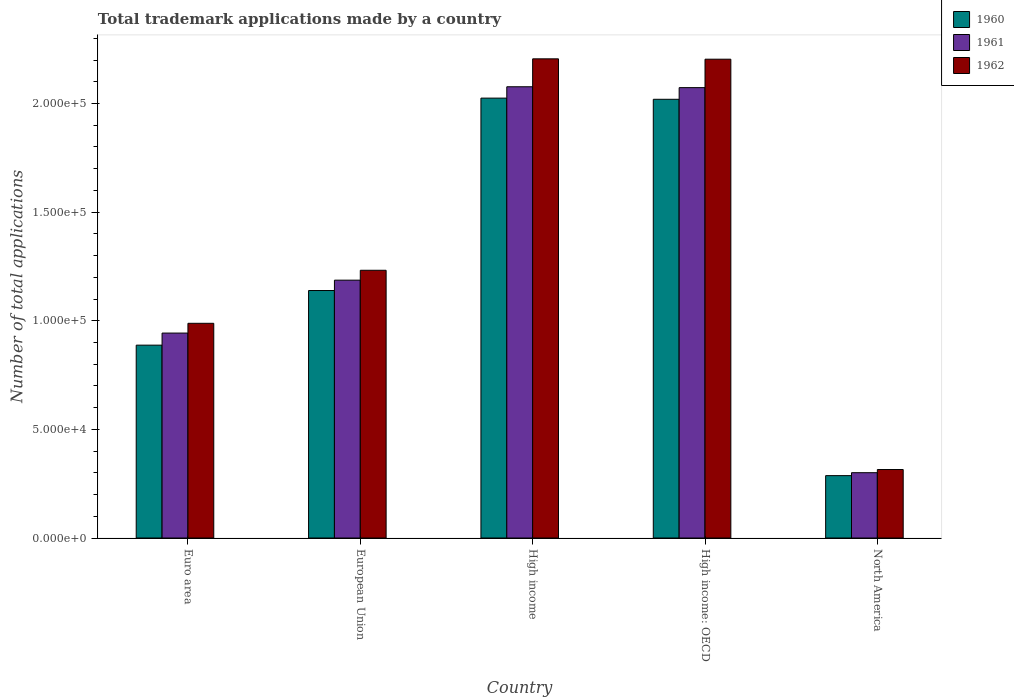How many different coloured bars are there?
Your answer should be compact. 3. How many bars are there on the 4th tick from the left?
Keep it short and to the point. 3. In how many cases, is the number of bars for a given country not equal to the number of legend labels?
Provide a succinct answer. 0. What is the number of applications made by in 1960 in European Union?
Ensure brevity in your answer.  1.14e+05. Across all countries, what is the maximum number of applications made by in 1961?
Offer a terse response. 2.08e+05. Across all countries, what is the minimum number of applications made by in 1960?
Ensure brevity in your answer.  2.87e+04. In which country was the number of applications made by in 1960 minimum?
Provide a succinct answer. North America. What is the total number of applications made by in 1961 in the graph?
Ensure brevity in your answer.  6.58e+05. What is the difference between the number of applications made by in 1960 in European Union and that in North America?
Your answer should be compact. 8.52e+04. What is the difference between the number of applications made by in 1962 in North America and the number of applications made by in 1961 in High income: OECD?
Provide a succinct answer. -1.76e+05. What is the average number of applications made by in 1961 per country?
Provide a succinct answer. 1.32e+05. What is the difference between the number of applications made by of/in 1961 and number of applications made by of/in 1962 in High income?
Your response must be concise. -1.29e+04. In how many countries, is the number of applications made by in 1960 greater than 180000?
Make the answer very short. 2. What is the ratio of the number of applications made by in 1962 in Euro area to that in European Union?
Provide a succinct answer. 0.8. What is the difference between the highest and the second highest number of applications made by in 1962?
Make the answer very short. 9.73e+04. What is the difference between the highest and the lowest number of applications made by in 1960?
Give a very brief answer. 1.74e+05. What does the 1st bar from the right in Euro area represents?
Ensure brevity in your answer.  1962. Is it the case that in every country, the sum of the number of applications made by in 1961 and number of applications made by in 1962 is greater than the number of applications made by in 1960?
Provide a short and direct response. Yes. How many countries are there in the graph?
Ensure brevity in your answer.  5. What is the difference between two consecutive major ticks on the Y-axis?
Provide a succinct answer. 5.00e+04. Does the graph contain grids?
Keep it short and to the point. No. How many legend labels are there?
Your response must be concise. 3. What is the title of the graph?
Ensure brevity in your answer.  Total trademark applications made by a country. Does "2002" appear as one of the legend labels in the graph?
Ensure brevity in your answer.  No. What is the label or title of the Y-axis?
Offer a terse response. Number of total applications. What is the Number of total applications in 1960 in Euro area?
Ensure brevity in your answer.  8.88e+04. What is the Number of total applications of 1961 in Euro area?
Ensure brevity in your answer.  9.43e+04. What is the Number of total applications in 1962 in Euro area?
Provide a short and direct response. 9.88e+04. What is the Number of total applications in 1960 in European Union?
Offer a very short reply. 1.14e+05. What is the Number of total applications of 1961 in European Union?
Provide a short and direct response. 1.19e+05. What is the Number of total applications in 1962 in European Union?
Offer a terse response. 1.23e+05. What is the Number of total applications of 1960 in High income?
Give a very brief answer. 2.02e+05. What is the Number of total applications of 1961 in High income?
Offer a very short reply. 2.08e+05. What is the Number of total applications in 1962 in High income?
Keep it short and to the point. 2.21e+05. What is the Number of total applications of 1960 in High income: OECD?
Your answer should be compact. 2.02e+05. What is the Number of total applications in 1961 in High income: OECD?
Your response must be concise. 2.07e+05. What is the Number of total applications in 1962 in High income: OECD?
Provide a succinct answer. 2.20e+05. What is the Number of total applications in 1960 in North America?
Your answer should be very brief. 2.87e+04. What is the Number of total applications of 1961 in North America?
Provide a succinct answer. 3.01e+04. What is the Number of total applications in 1962 in North America?
Your answer should be very brief. 3.15e+04. Across all countries, what is the maximum Number of total applications of 1960?
Provide a succinct answer. 2.02e+05. Across all countries, what is the maximum Number of total applications of 1961?
Offer a very short reply. 2.08e+05. Across all countries, what is the maximum Number of total applications in 1962?
Provide a short and direct response. 2.21e+05. Across all countries, what is the minimum Number of total applications of 1960?
Make the answer very short. 2.87e+04. Across all countries, what is the minimum Number of total applications of 1961?
Your response must be concise. 3.01e+04. Across all countries, what is the minimum Number of total applications of 1962?
Ensure brevity in your answer.  3.15e+04. What is the total Number of total applications of 1960 in the graph?
Provide a short and direct response. 6.36e+05. What is the total Number of total applications of 1961 in the graph?
Your response must be concise. 6.58e+05. What is the total Number of total applications of 1962 in the graph?
Your response must be concise. 6.95e+05. What is the difference between the Number of total applications in 1960 in Euro area and that in European Union?
Offer a terse response. -2.51e+04. What is the difference between the Number of total applications in 1961 in Euro area and that in European Union?
Make the answer very short. -2.44e+04. What is the difference between the Number of total applications of 1962 in Euro area and that in European Union?
Your response must be concise. -2.44e+04. What is the difference between the Number of total applications in 1960 in Euro area and that in High income?
Ensure brevity in your answer.  -1.14e+05. What is the difference between the Number of total applications of 1961 in Euro area and that in High income?
Your answer should be compact. -1.13e+05. What is the difference between the Number of total applications of 1962 in Euro area and that in High income?
Your answer should be very brief. -1.22e+05. What is the difference between the Number of total applications of 1960 in Euro area and that in High income: OECD?
Your response must be concise. -1.13e+05. What is the difference between the Number of total applications in 1961 in Euro area and that in High income: OECD?
Your answer should be compact. -1.13e+05. What is the difference between the Number of total applications of 1962 in Euro area and that in High income: OECD?
Give a very brief answer. -1.22e+05. What is the difference between the Number of total applications of 1960 in Euro area and that in North America?
Your answer should be very brief. 6.01e+04. What is the difference between the Number of total applications of 1961 in Euro area and that in North America?
Your response must be concise. 6.43e+04. What is the difference between the Number of total applications of 1962 in Euro area and that in North America?
Offer a terse response. 6.73e+04. What is the difference between the Number of total applications in 1960 in European Union and that in High income?
Your answer should be compact. -8.86e+04. What is the difference between the Number of total applications in 1961 in European Union and that in High income?
Provide a succinct answer. -8.90e+04. What is the difference between the Number of total applications in 1962 in European Union and that in High income?
Keep it short and to the point. -9.73e+04. What is the difference between the Number of total applications in 1960 in European Union and that in High income: OECD?
Keep it short and to the point. -8.80e+04. What is the difference between the Number of total applications of 1961 in European Union and that in High income: OECD?
Offer a terse response. -8.86e+04. What is the difference between the Number of total applications of 1962 in European Union and that in High income: OECD?
Offer a very short reply. -9.72e+04. What is the difference between the Number of total applications of 1960 in European Union and that in North America?
Ensure brevity in your answer.  8.52e+04. What is the difference between the Number of total applications of 1961 in European Union and that in North America?
Give a very brief answer. 8.86e+04. What is the difference between the Number of total applications of 1962 in European Union and that in North America?
Your response must be concise. 9.17e+04. What is the difference between the Number of total applications in 1960 in High income and that in High income: OECD?
Offer a terse response. 540. What is the difference between the Number of total applications in 1961 in High income and that in High income: OECD?
Offer a very short reply. 401. What is the difference between the Number of total applications of 1962 in High income and that in High income: OECD?
Keep it short and to the point. 170. What is the difference between the Number of total applications of 1960 in High income and that in North America?
Give a very brief answer. 1.74e+05. What is the difference between the Number of total applications of 1961 in High income and that in North America?
Offer a very short reply. 1.78e+05. What is the difference between the Number of total applications of 1962 in High income and that in North America?
Provide a short and direct response. 1.89e+05. What is the difference between the Number of total applications in 1960 in High income: OECD and that in North America?
Offer a terse response. 1.73e+05. What is the difference between the Number of total applications in 1961 in High income: OECD and that in North America?
Offer a terse response. 1.77e+05. What is the difference between the Number of total applications of 1962 in High income: OECD and that in North America?
Provide a short and direct response. 1.89e+05. What is the difference between the Number of total applications in 1960 in Euro area and the Number of total applications in 1961 in European Union?
Give a very brief answer. -2.99e+04. What is the difference between the Number of total applications in 1960 in Euro area and the Number of total applications in 1962 in European Union?
Your answer should be compact. -3.45e+04. What is the difference between the Number of total applications of 1961 in Euro area and the Number of total applications of 1962 in European Union?
Make the answer very short. -2.89e+04. What is the difference between the Number of total applications of 1960 in Euro area and the Number of total applications of 1961 in High income?
Ensure brevity in your answer.  -1.19e+05. What is the difference between the Number of total applications in 1960 in Euro area and the Number of total applications in 1962 in High income?
Ensure brevity in your answer.  -1.32e+05. What is the difference between the Number of total applications in 1961 in Euro area and the Number of total applications in 1962 in High income?
Ensure brevity in your answer.  -1.26e+05. What is the difference between the Number of total applications in 1960 in Euro area and the Number of total applications in 1961 in High income: OECD?
Ensure brevity in your answer.  -1.19e+05. What is the difference between the Number of total applications in 1960 in Euro area and the Number of total applications in 1962 in High income: OECD?
Your answer should be compact. -1.32e+05. What is the difference between the Number of total applications of 1961 in Euro area and the Number of total applications of 1962 in High income: OECD?
Offer a terse response. -1.26e+05. What is the difference between the Number of total applications in 1960 in Euro area and the Number of total applications in 1961 in North America?
Provide a succinct answer. 5.87e+04. What is the difference between the Number of total applications of 1960 in Euro area and the Number of total applications of 1962 in North America?
Your answer should be very brief. 5.72e+04. What is the difference between the Number of total applications of 1961 in Euro area and the Number of total applications of 1962 in North America?
Your answer should be compact. 6.28e+04. What is the difference between the Number of total applications in 1960 in European Union and the Number of total applications in 1961 in High income?
Make the answer very short. -9.38e+04. What is the difference between the Number of total applications in 1960 in European Union and the Number of total applications in 1962 in High income?
Make the answer very short. -1.07e+05. What is the difference between the Number of total applications in 1961 in European Union and the Number of total applications in 1962 in High income?
Your answer should be compact. -1.02e+05. What is the difference between the Number of total applications in 1960 in European Union and the Number of total applications in 1961 in High income: OECD?
Keep it short and to the point. -9.34e+04. What is the difference between the Number of total applications in 1960 in European Union and the Number of total applications in 1962 in High income: OECD?
Provide a short and direct response. -1.06e+05. What is the difference between the Number of total applications of 1961 in European Union and the Number of total applications of 1962 in High income: OECD?
Offer a terse response. -1.02e+05. What is the difference between the Number of total applications of 1960 in European Union and the Number of total applications of 1961 in North America?
Keep it short and to the point. 8.39e+04. What is the difference between the Number of total applications in 1960 in European Union and the Number of total applications in 1962 in North America?
Your answer should be very brief. 8.24e+04. What is the difference between the Number of total applications in 1961 in European Union and the Number of total applications in 1962 in North America?
Your response must be concise. 8.72e+04. What is the difference between the Number of total applications in 1960 in High income and the Number of total applications in 1961 in High income: OECD?
Your response must be concise. -4828. What is the difference between the Number of total applications in 1960 in High income and the Number of total applications in 1962 in High income: OECD?
Provide a short and direct response. -1.79e+04. What is the difference between the Number of total applications in 1961 in High income and the Number of total applications in 1962 in High income: OECD?
Provide a short and direct response. -1.27e+04. What is the difference between the Number of total applications of 1960 in High income and the Number of total applications of 1961 in North America?
Offer a terse response. 1.72e+05. What is the difference between the Number of total applications of 1960 in High income and the Number of total applications of 1962 in North America?
Your answer should be very brief. 1.71e+05. What is the difference between the Number of total applications in 1961 in High income and the Number of total applications in 1962 in North America?
Provide a short and direct response. 1.76e+05. What is the difference between the Number of total applications in 1960 in High income: OECD and the Number of total applications in 1961 in North America?
Ensure brevity in your answer.  1.72e+05. What is the difference between the Number of total applications in 1960 in High income: OECD and the Number of total applications in 1962 in North America?
Give a very brief answer. 1.70e+05. What is the difference between the Number of total applications in 1961 in High income: OECD and the Number of total applications in 1962 in North America?
Give a very brief answer. 1.76e+05. What is the average Number of total applications in 1960 per country?
Provide a succinct answer. 1.27e+05. What is the average Number of total applications in 1961 per country?
Provide a succinct answer. 1.32e+05. What is the average Number of total applications of 1962 per country?
Your answer should be very brief. 1.39e+05. What is the difference between the Number of total applications of 1960 and Number of total applications of 1961 in Euro area?
Offer a very short reply. -5562. What is the difference between the Number of total applications of 1960 and Number of total applications of 1962 in Euro area?
Ensure brevity in your answer.  -1.01e+04. What is the difference between the Number of total applications in 1961 and Number of total applications in 1962 in Euro area?
Offer a very short reply. -4494. What is the difference between the Number of total applications of 1960 and Number of total applications of 1961 in European Union?
Provide a succinct answer. -4767. What is the difference between the Number of total applications of 1960 and Number of total applications of 1962 in European Union?
Provide a short and direct response. -9317. What is the difference between the Number of total applications of 1961 and Number of total applications of 1962 in European Union?
Your answer should be compact. -4550. What is the difference between the Number of total applications in 1960 and Number of total applications in 1961 in High income?
Give a very brief answer. -5229. What is the difference between the Number of total applications in 1960 and Number of total applications in 1962 in High income?
Offer a very short reply. -1.81e+04. What is the difference between the Number of total applications of 1961 and Number of total applications of 1962 in High income?
Your answer should be very brief. -1.29e+04. What is the difference between the Number of total applications of 1960 and Number of total applications of 1961 in High income: OECD?
Offer a very short reply. -5368. What is the difference between the Number of total applications in 1960 and Number of total applications in 1962 in High income: OECD?
Give a very brief answer. -1.85e+04. What is the difference between the Number of total applications in 1961 and Number of total applications in 1962 in High income: OECD?
Your response must be concise. -1.31e+04. What is the difference between the Number of total applications of 1960 and Number of total applications of 1961 in North America?
Provide a short and direct response. -1355. What is the difference between the Number of total applications in 1960 and Number of total applications in 1962 in North America?
Ensure brevity in your answer.  -2817. What is the difference between the Number of total applications of 1961 and Number of total applications of 1962 in North America?
Your answer should be very brief. -1462. What is the ratio of the Number of total applications of 1960 in Euro area to that in European Union?
Your response must be concise. 0.78. What is the ratio of the Number of total applications in 1961 in Euro area to that in European Union?
Provide a short and direct response. 0.79. What is the ratio of the Number of total applications of 1962 in Euro area to that in European Union?
Provide a succinct answer. 0.8. What is the ratio of the Number of total applications of 1960 in Euro area to that in High income?
Provide a short and direct response. 0.44. What is the ratio of the Number of total applications in 1961 in Euro area to that in High income?
Ensure brevity in your answer.  0.45. What is the ratio of the Number of total applications in 1962 in Euro area to that in High income?
Make the answer very short. 0.45. What is the ratio of the Number of total applications of 1960 in Euro area to that in High income: OECD?
Offer a terse response. 0.44. What is the ratio of the Number of total applications of 1961 in Euro area to that in High income: OECD?
Give a very brief answer. 0.46. What is the ratio of the Number of total applications of 1962 in Euro area to that in High income: OECD?
Provide a succinct answer. 0.45. What is the ratio of the Number of total applications of 1960 in Euro area to that in North America?
Make the answer very short. 3.09. What is the ratio of the Number of total applications of 1961 in Euro area to that in North America?
Offer a terse response. 3.14. What is the ratio of the Number of total applications in 1962 in Euro area to that in North America?
Your answer should be compact. 3.13. What is the ratio of the Number of total applications in 1960 in European Union to that in High income?
Make the answer very short. 0.56. What is the ratio of the Number of total applications in 1962 in European Union to that in High income?
Give a very brief answer. 0.56. What is the ratio of the Number of total applications of 1960 in European Union to that in High income: OECD?
Offer a very short reply. 0.56. What is the ratio of the Number of total applications of 1961 in European Union to that in High income: OECD?
Keep it short and to the point. 0.57. What is the ratio of the Number of total applications of 1962 in European Union to that in High income: OECD?
Provide a short and direct response. 0.56. What is the ratio of the Number of total applications in 1960 in European Union to that in North America?
Keep it short and to the point. 3.97. What is the ratio of the Number of total applications in 1961 in European Union to that in North America?
Make the answer very short. 3.95. What is the ratio of the Number of total applications of 1962 in European Union to that in North America?
Provide a succinct answer. 3.91. What is the ratio of the Number of total applications in 1960 in High income to that in High income: OECD?
Offer a very short reply. 1. What is the ratio of the Number of total applications in 1962 in High income to that in High income: OECD?
Keep it short and to the point. 1. What is the ratio of the Number of total applications of 1960 in High income to that in North America?
Your answer should be very brief. 7.05. What is the ratio of the Number of total applications in 1961 in High income to that in North America?
Make the answer very short. 6.91. What is the ratio of the Number of total applications of 1962 in High income to that in North America?
Provide a short and direct response. 7. What is the ratio of the Number of total applications of 1960 in High income: OECD to that in North America?
Make the answer very short. 7.03. What is the ratio of the Number of total applications of 1961 in High income: OECD to that in North America?
Make the answer very short. 6.9. What is the ratio of the Number of total applications of 1962 in High income: OECD to that in North America?
Your response must be concise. 6.99. What is the difference between the highest and the second highest Number of total applications in 1960?
Provide a succinct answer. 540. What is the difference between the highest and the second highest Number of total applications in 1961?
Make the answer very short. 401. What is the difference between the highest and the second highest Number of total applications in 1962?
Offer a very short reply. 170. What is the difference between the highest and the lowest Number of total applications of 1960?
Your answer should be compact. 1.74e+05. What is the difference between the highest and the lowest Number of total applications of 1961?
Offer a terse response. 1.78e+05. What is the difference between the highest and the lowest Number of total applications in 1962?
Make the answer very short. 1.89e+05. 